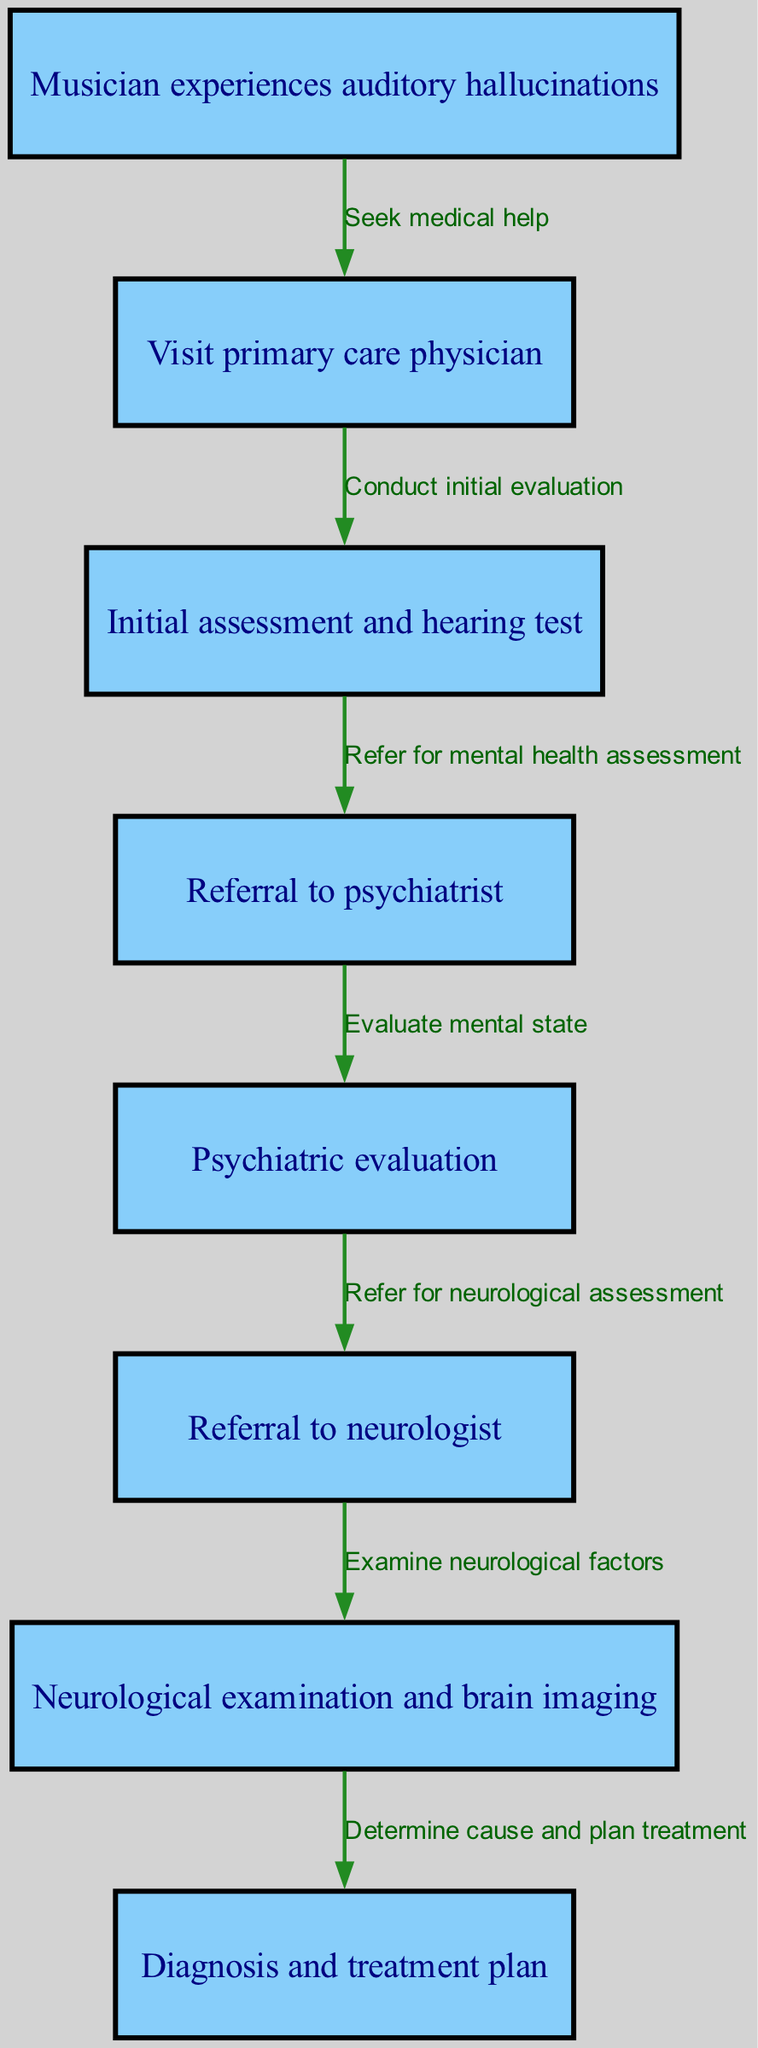What is the first step a musician should take when experiencing auditory hallucinations? The diagram starts with the node "Musician experiences auditory hallucinations," which leads to the first action of seeking medical help by visiting a primary care physician.
Answer: Visit primary care physician How many total nodes are present in the diagram? By counting the nodes listed in the diagram, there are a total of 8 nodes, including the starting point.
Answer: 8 What type of evaluation is conducted after the initial assessment? The initial assessment leads to a referral for a mental health assessment, which is carried out through a psychiatric evaluation.
Answer: Psychiatric evaluation Which specialist does the musician see after the psychiatrist? After the psychiatric evaluation, the musician is referred to a neurologist to assess any neurological factors contributing to their auditory hallucinations.
Answer: Neurologist What is the outcome of the neurological exam? Following the neurological exam, the next step is to determine the cause of the hallucinations and establish a treatment plan.
Answer: Diagnosis and treatment plan What relationship exists between the primary care physician and the referral to psychiatry? The relationship is directed; the primary care physician conducts the initial evaluation, which leads to a referral to a psychiatrist for further assessment.
Answer: Refer for mental health assessment What is the immediate action taken after seeking medical help? The musician seeks medical help by visiting the primary care physician, who then conducts the initial evaluation.
Answer: Conduct initial evaluation What kind of test is included in the initial assessment by the primary care physician? The initial assessment includes a hearing test to rule out any auditory issues before proceeding to further assessments.
Answer: Hearing test What diagnostic procedure follows the neurological exam? Upon completion of the neurological examination, the next step is to determine the cause of the symptoms and create a treatment plan.
Answer: Diagnosis and treatment plan 